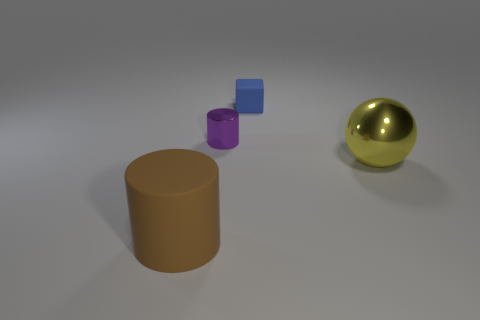What is the size of the rubber object that is right of the big cylinder?
Give a very brief answer. Small. How many other things are there of the same material as the small cube?
Give a very brief answer. 1. Are there any tiny cylinders that are behind the metal cylinder that is to the right of the brown object?
Provide a succinct answer. No. Is there anything else that is the same shape as the big brown rubber thing?
Ensure brevity in your answer.  Yes. There is another small metal thing that is the same shape as the brown thing; what color is it?
Give a very brief answer. Purple. What is the size of the purple metal object?
Give a very brief answer. Small. Is the number of rubber cylinders to the right of the tiny blue thing less than the number of red objects?
Your answer should be very brief. No. Is the material of the large sphere the same as the large object that is on the left side of the blue rubber block?
Your answer should be compact. No. There is a rubber object behind the object in front of the large metallic ball; is there a large shiny object that is behind it?
Provide a short and direct response. No. Are there any other things that are the same size as the blue rubber thing?
Offer a terse response. Yes. 